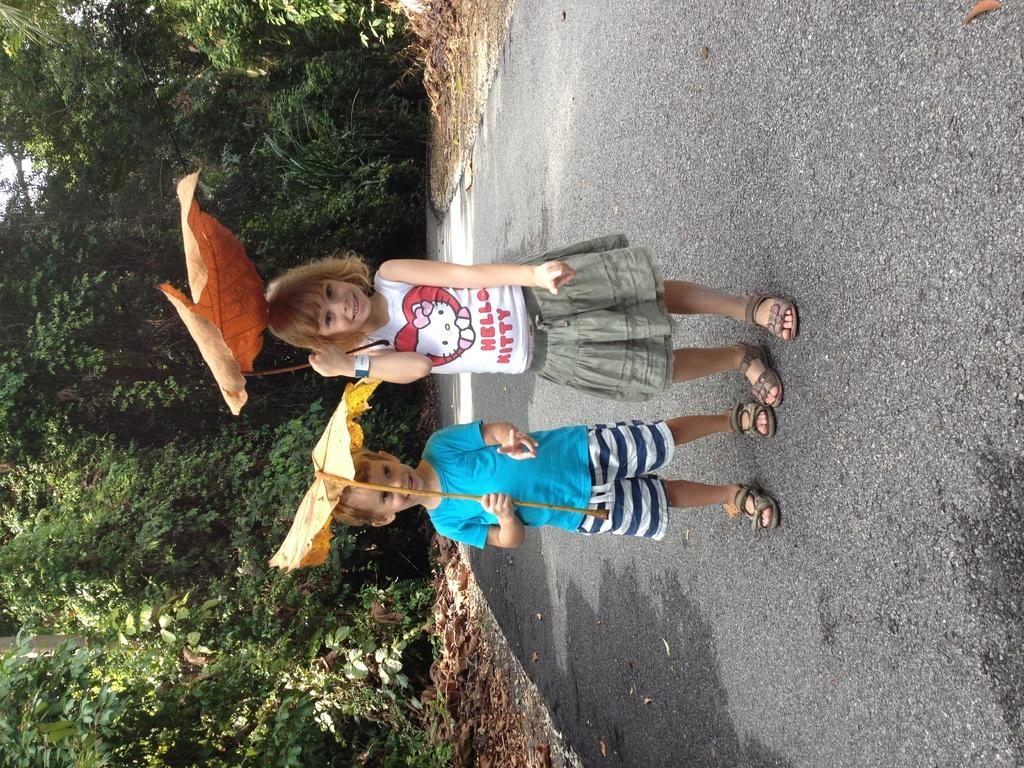<image>
Relay a brief, clear account of the picture shown. A boy with a giant yellow leaf on his head standing next to his older sister, who also has a leaf on her head and wearing a Hello Kitty shirt 